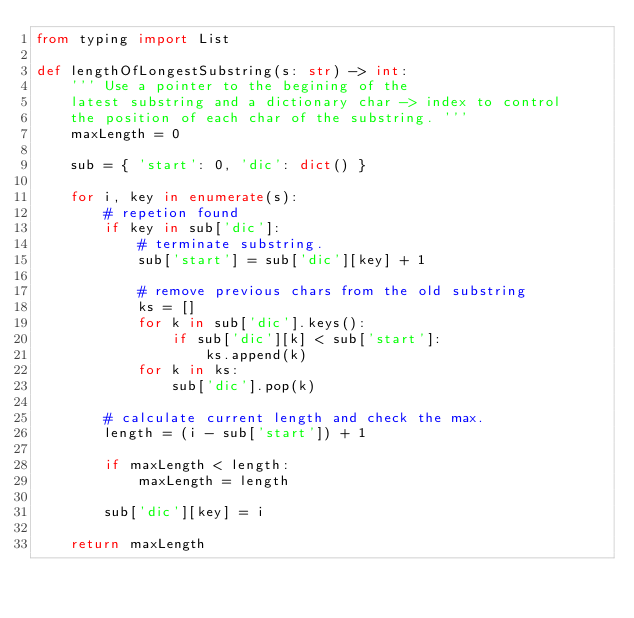<code> <loc_0><loc_0><loc_500><loc_500><_Python_>from typing import List

def lengthOfLongestSubstring(s: str) -> int:
    ''' Use a pointer to the begining of the 
    latest substring and a dictionary char -> index to control 
    the position of each char of the substring. '''
    maxLength = 0
    
    sub = { 'start': 0, 'dic': dict() }

    for i, key in enumerate(s):
        # repetion found
        if key in sub['dic']:
            # terminate substring.
            sub['start'] = sub['dic'][key] + 1

            # remove previous chars from the old substring
            ks = []
            for k in sub['dic'].keys():
                if sub['dic'][k] < sub['start']:
                    ks.append(k)
            for k in ks:
                sub['dic'].pop(k)

        # calculate current length and check the max.
        length = (i - sub['start']) + 1

        if maxLength < length:
            maxLength = length
        
        sub['dic'][key] = i

    return maxLength
</code> 